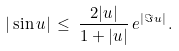<formula> <loc_0><loc_0><loc_500><loc_500>| \sin u | \, \leq \, \frac { 2 | u | } { 1 + | u | } \, e ^ { | \Im u | } \, .</formula> 